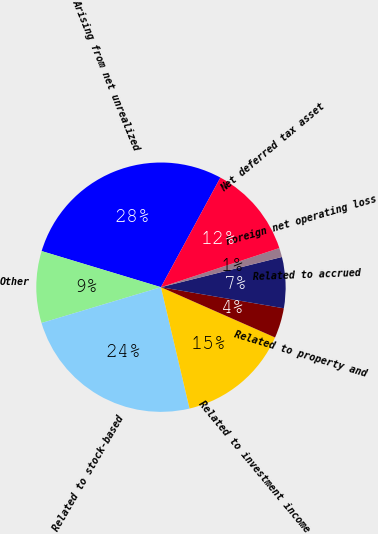Convert chart to OTSL. <chart><loc_0><loc_0><loc_500><loc_500><pie_chart><fcel>Arising from net unrealized<fcel>Other<fcel>Related to stock-based<fcel>Related to investment income<fcel>Related to property and<fcel>Related to accrued<fcel>Foreign net operating loss<fcel>Net deferred tax asset<nl><fcel>28.23%<fcel>9.31%<fcel>24.05%<fcel>14.71%<fcel>3.9%<fcel>6.6%<fcel>1.19%<fcel>12.01%<nl></chart> 